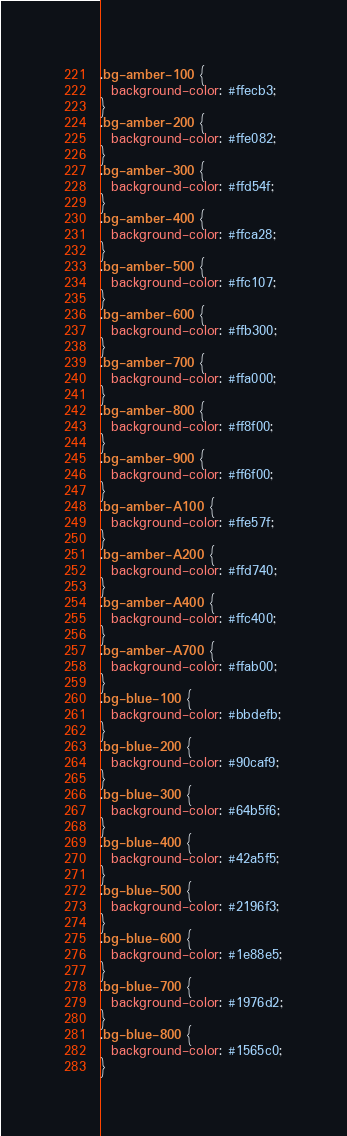Convert code to text. <code><loc_0><loc_0><loc_500><loc_500><_CSS_>.bg-amber-100 {
  background-color: #ffecb3;
}
.bg-amber-200 {
  background-color: #ffe082;
}
.bg-amber-300 {
  background-color: #ffd54f;
}
.bg-amber-400 {
  background-color: #ffca28;
}
.bg-amber-500 {
  background-color: #ffc107;
}
.bg-amber-600 {
  background-color: #ffb300;
}
.bg-amber-700 {
  background-color: #ffa000;
}
.bg-amber-800 {
  background-color: #ff8f00;
}
.bg-amber-900 {
  background-color: #ff6f00;
}
.bg-amber-A100 {
  background-color: #ffe57f;
}
.bg-amber-A200 {
  background-color: #ffd740;
}
.bg-amber-A400 {
  background-color: #ffc400;
}
.bg-amber-A700 {
  background-color: #ffab00;
}
.bg-blue-100 {
  background-color: #bbdefb;
}
.bg-blue-200 {
  background-color: #90caf9;
}
.bg-blue-300 {
  background-color: #64b5f6;
}
.bg-blue-400 {
  background-color: #42a5f5;
}
.bg-blue-500 {
  background-color: #2196f3;
}
.bg-blue-600 {
  background-color: #1e88e5;
}
.bg-blue-700 {
  background-color: #1976d2;
}
.bg-blue-800 {
  background-color: #1565c0;
}</code> 